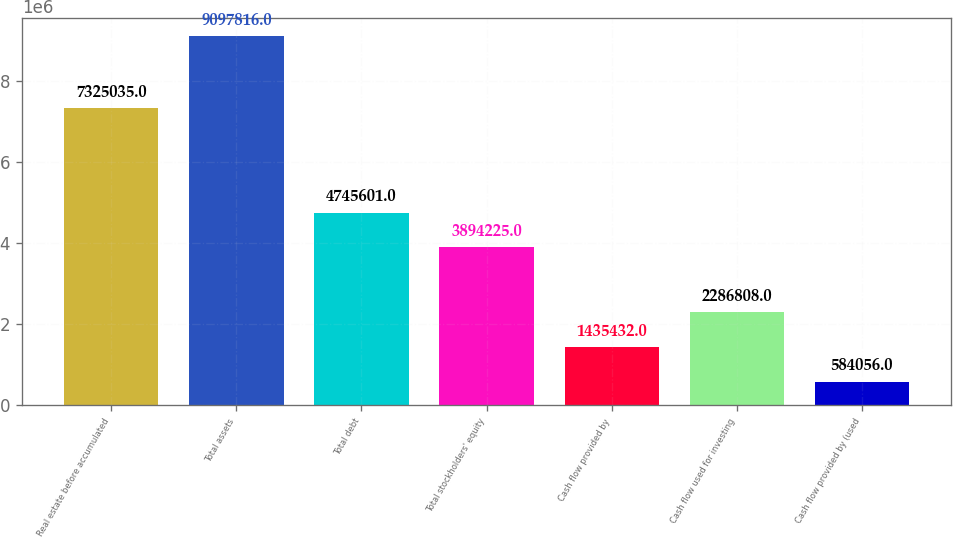Convert chart. <chart><loc_0><loc_0><loc_500><loc_500><bar_chart><fcel>Real estate before accumulated<fcel>Total assets<fcel>Total debt<fcel>Total stockholders' equity<fcel>Cash flow provided by<fcel>Cash flow used for investing<fcel>Cash flow provided by (used<nl><fcel>7.32504e+06<fcel>9.09782e+06<fcel>4.7456e+06<fcel>3.89422e+06<fcel>1.43543e+06<fcel>2.28681e+06<fcel>584056<nl></chart> 